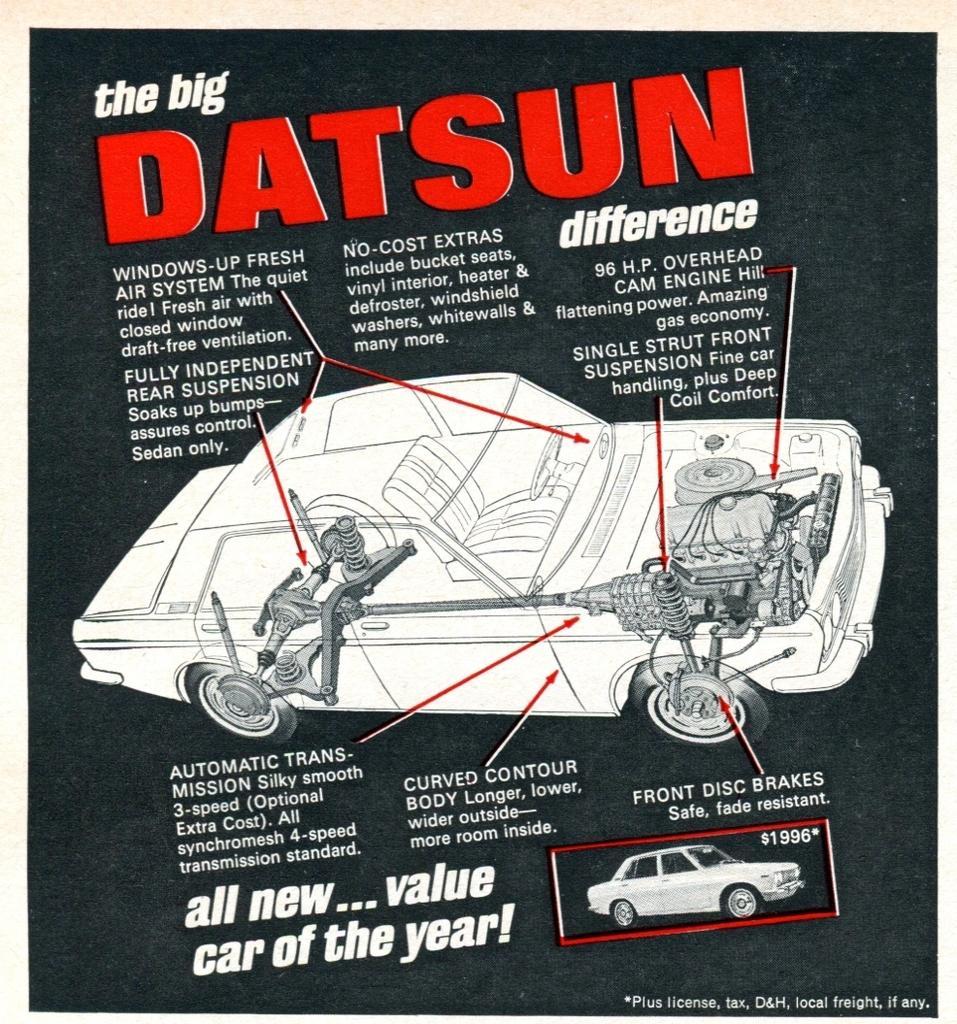Could you give a brief overview of what you see in this image? This is a poster image in which there is some text and there is a image of the car. 